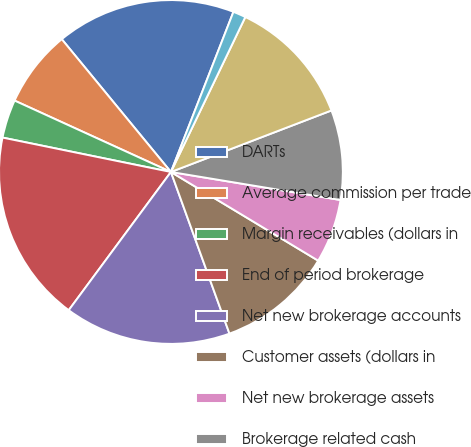Convert chart to OTSL. <chart><loc_0><loc_0><loc_500><loc_500><pie_chart><fcel>DARTs<fcel>Average commission per trade<fcel>Margin receivables (dollars in<fcel>End of period brokerage<fcel>Net new brokerage accounts<fcel>Customer assets (dollars in<fcel>Net new brokerage assets<fcel>Brokerage related cash<fcel>Corporate cash (dollars in<fcel>ETRADE Financial Tier 1<nl><fcel>16.87%<fcel>7.23%<fcel>3.61%<fcel>18.07%<fcel>15.66%<fcel>10.84%<fcel>6.02%<fcel>8.43%<fcel>12.05%<fcel>1.2%<nl></chart> 